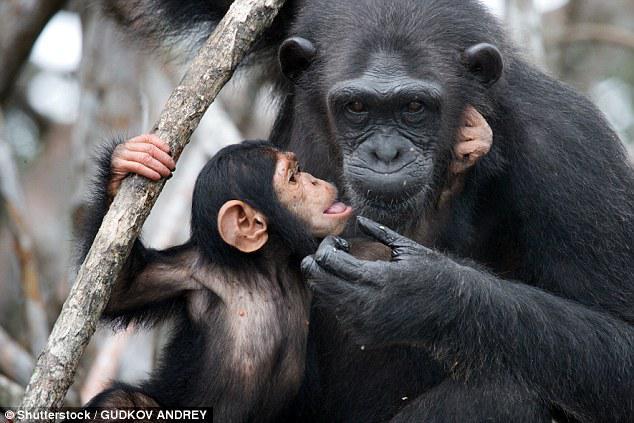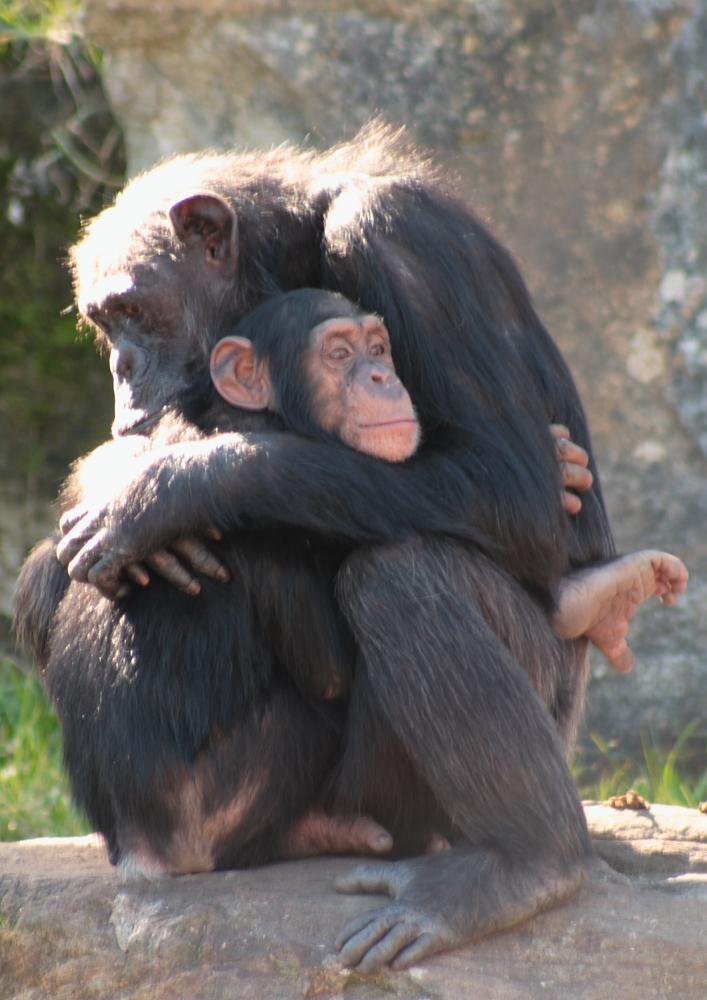The first image is the image on the left, the second image is the image on the right. Analyze the images presented: Is the assertion "Two primates sit in a grassy area in the image on the right." valid? Answer yes or no. No. The first image is the image on the left, the second image is the image on the right. Analyze the images presented: Is the assertion "An image shows a pair of squatting apes that each hold a food-type item in one hand." valid? Answer yes or no. No. 